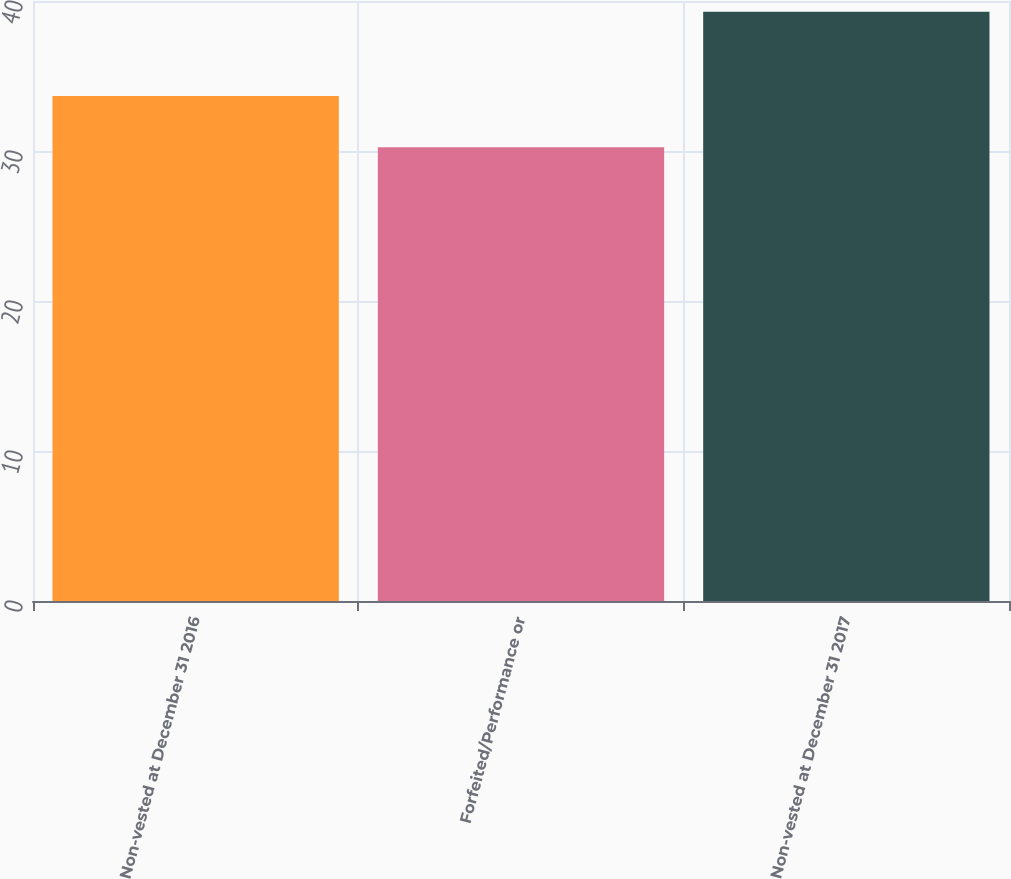<chart> <loc_0><loc_0><loc_500><loc_500><bar_chart><fcel>Non-vested at December 31 2016<fcel>Forfeited/Performance or<fcel>Non-vested at December 31 2017<nl><fcel>33.67<fcel>30.25<fcel>39.28<nl></chart> 